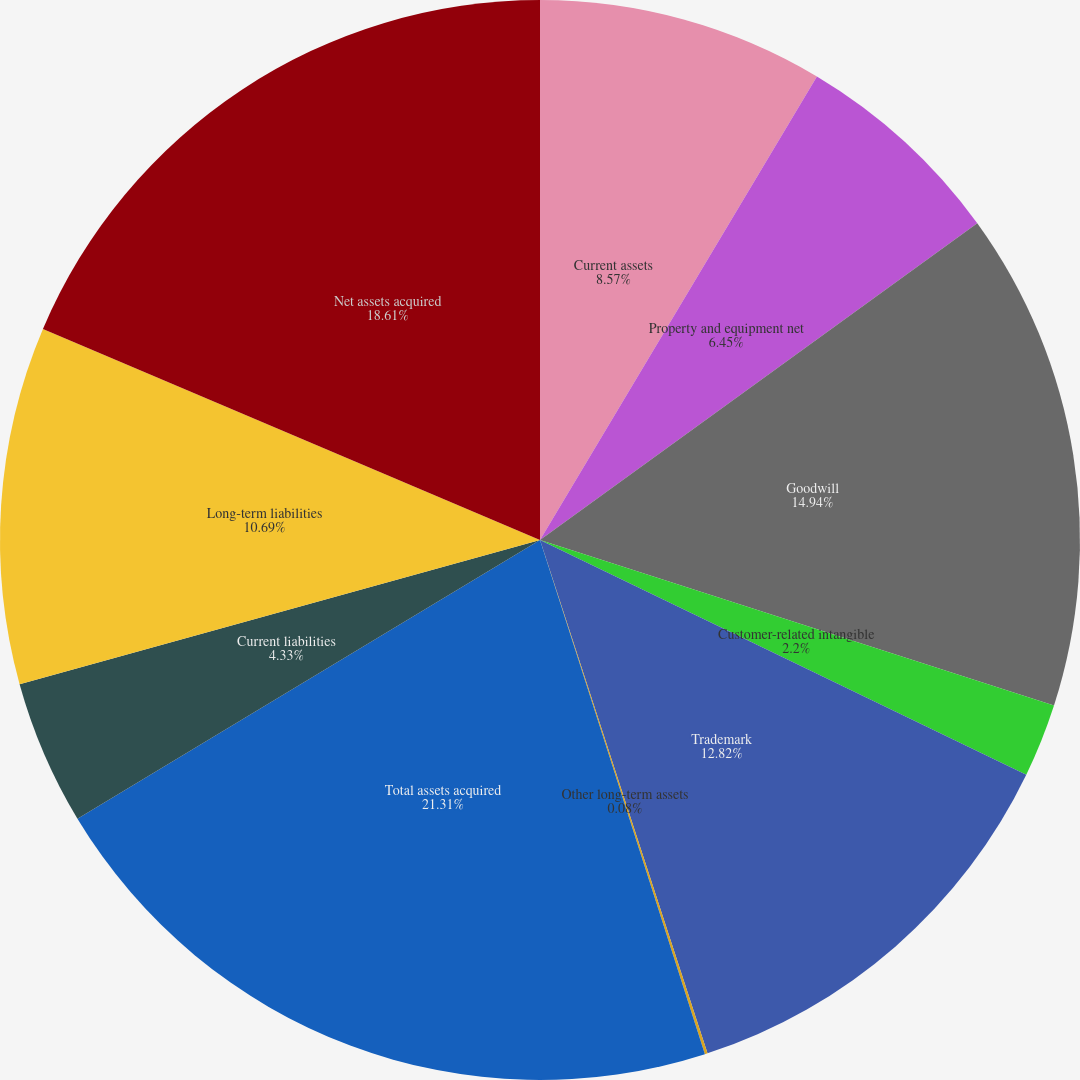Convert chart to OTSL. <chart><loc_0><loc_0><loc_500><loc_500><pie_chart><fcel>Current assets<fcel>Property and equipment net<fcel>Goodwill<fcel>Customer-related intangible<fcel>Trademark<fcel>Other long-term assets<fcel>Total assets acquired<fcel>Current liabilities<fcel>Long-term liabilities<fcel>Net assets acquired<nl><fcel>8.57%<fcel>6.45%<fcel>14.94%<fcel>2.2%<fcel>12.82%<fcel>0.08%<fcel>21.31%<fcel>4.33%<fcel>10.69%<fcel>18.61%<nl></chart> 